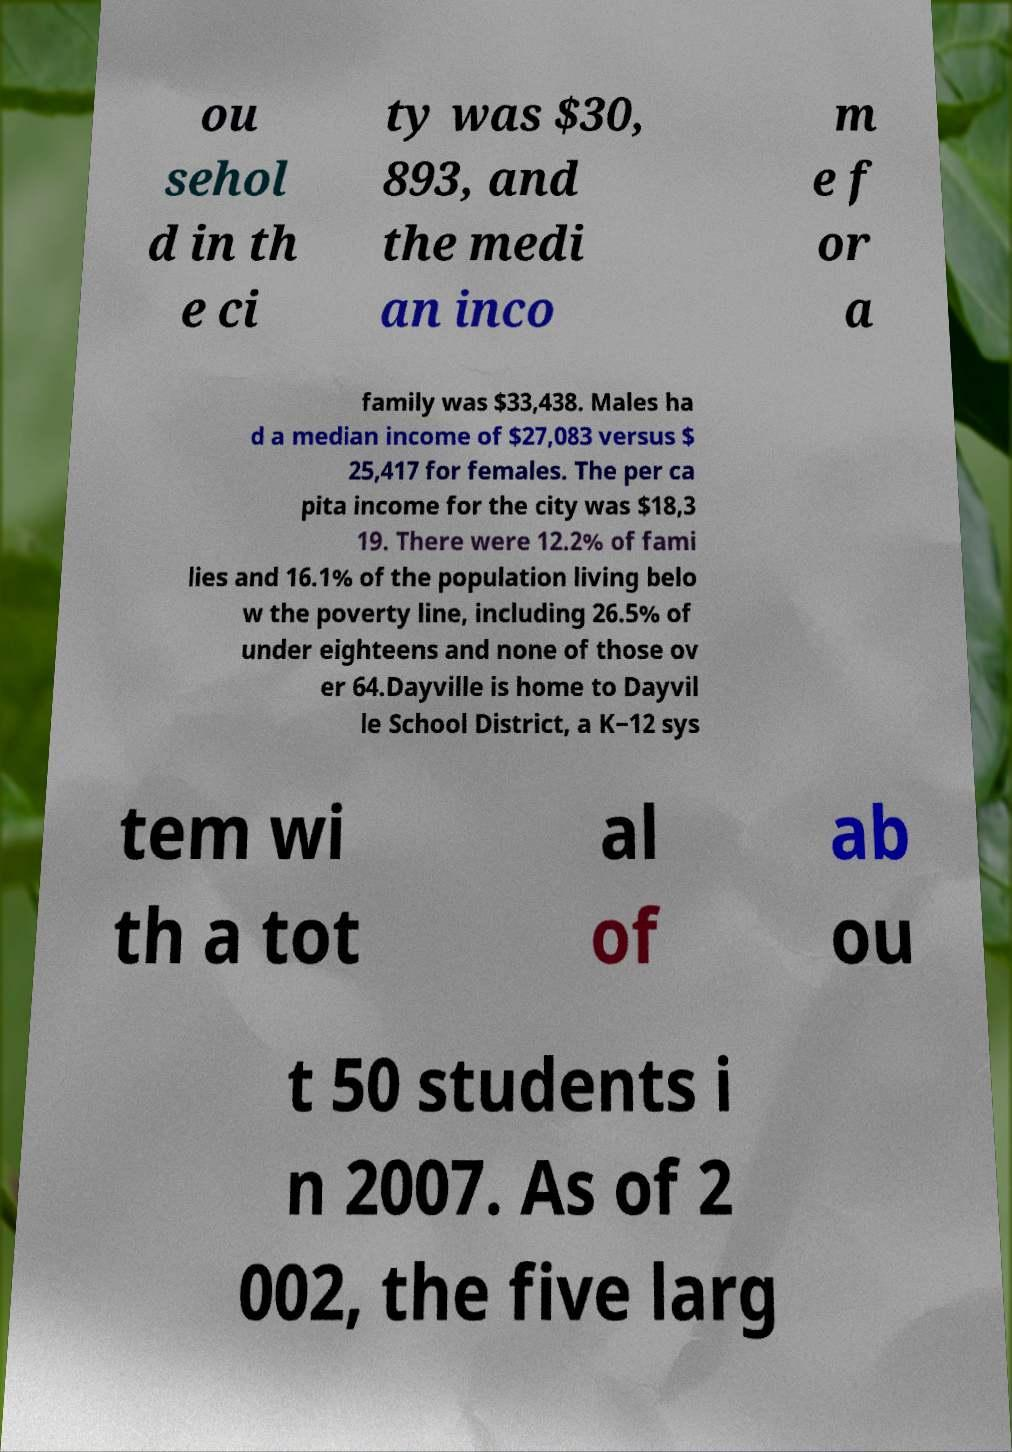Could you extract and type out the text from this image? ou sehol d in th e ci ty was $30, 893, and the medi an inco m e f or a family was $33,438. Males ha d a median income of $27,083 versus $ 25,417 for females. The per ca pita income for the city was $18,3 19. There were 12.2% of fami lies and 16.1% of the population living belo w the poverty line, including 26.5% of under eighteens and none of those ov er 64.Dayville is home to Dayvil le School District, a K−12 sys tem wi th a tot al of ab ou t 50 students i n 2007. As of 2 002, the five larg 